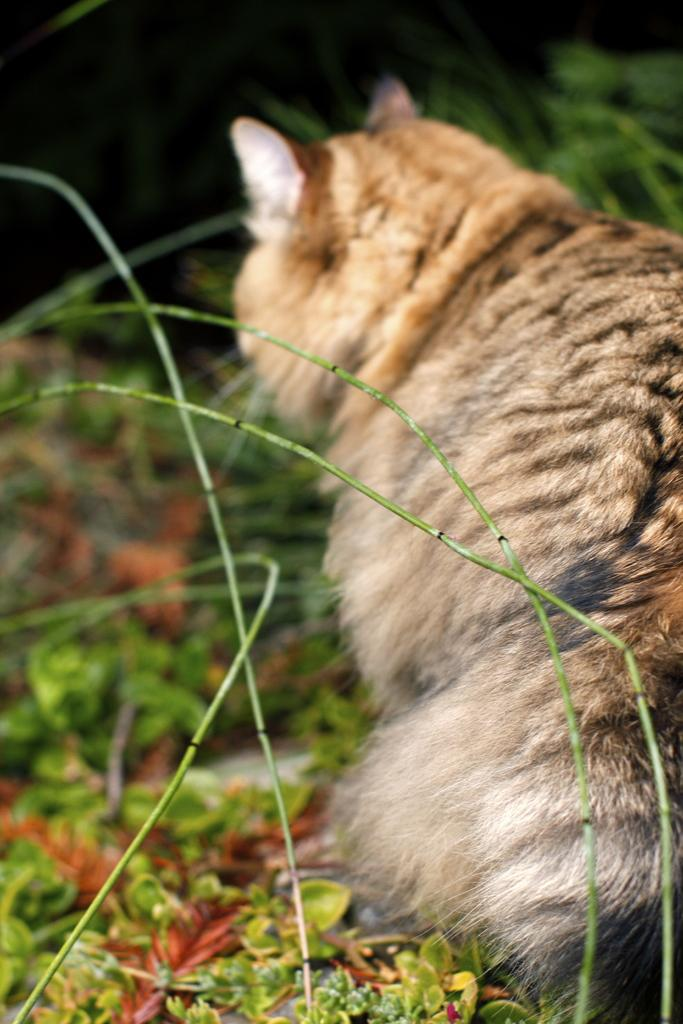What type of animal can be seen on the right side of the image? There is an animal on the right side of the image, but the specific type cannot be determined from the provided facts. What is located on the left side of the image? There are stems and plants on the left side of the image. What can be seen in the background of the image? There are plants in the background of the image. How would you describe the color of the background in the image? The background of the image is dark in color. Can you hear the sound of thunder in the image? There is no sound present in the image, so it is not possible to hear thunder or any other sound. Is the animal on the right side of the image made of gold? There is no mention of gold or any other material in the description of the animal, so it cannot be determined from the provided facts. 